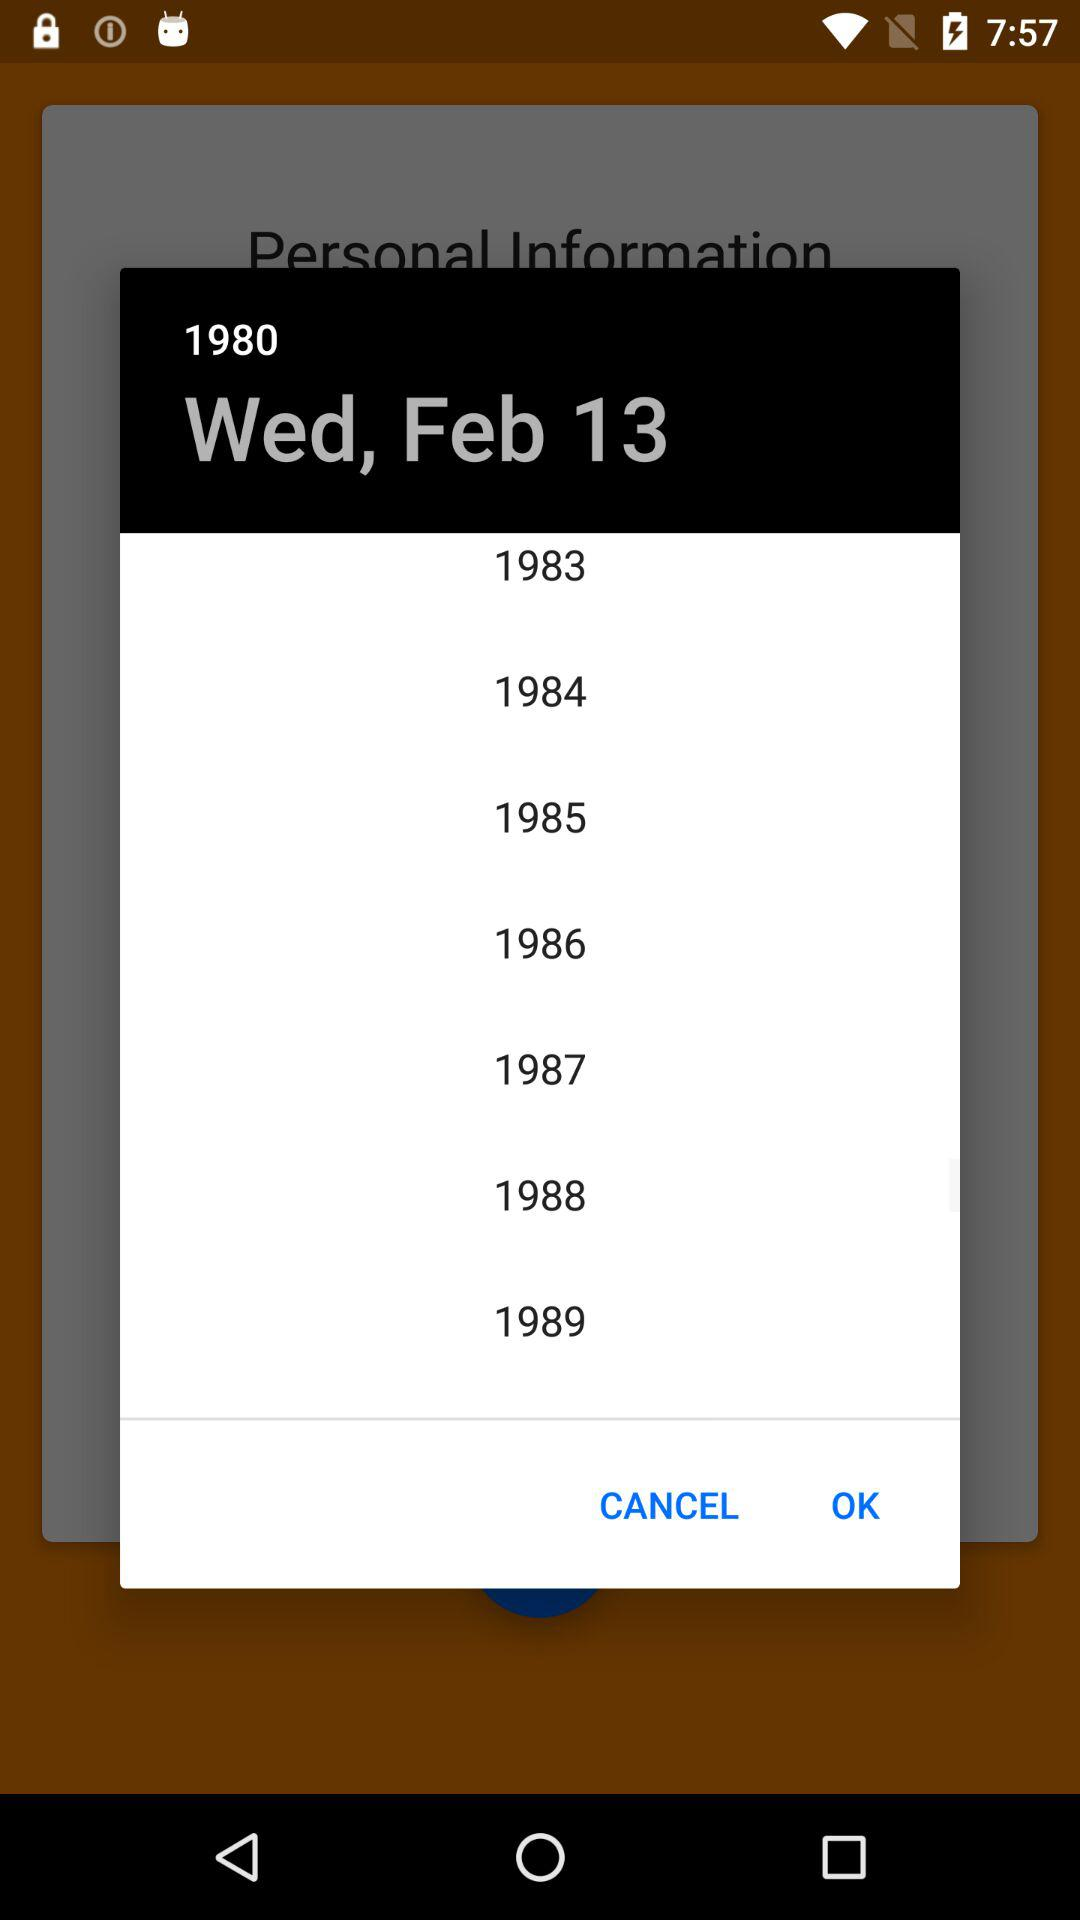Which year is selected? The selected year is 1980. 